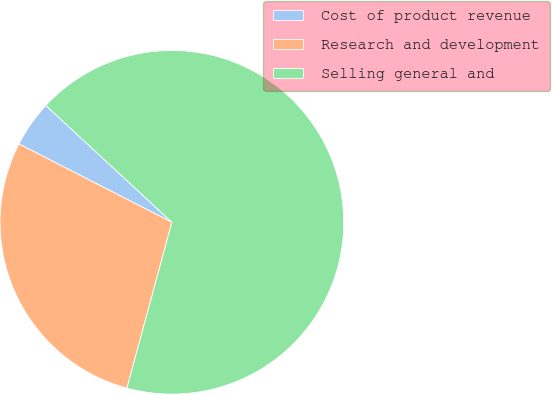Convert chart to OTSL. <chart><loc_0><loc_0><loc_500><loc_500><pie_chart><fcel>Cost of product revenue<fcel>Research and development<fcel>Selling general and<nl><fcel>4.36%<fcel>28.32%<fcel>67.32%<nl></chart> 